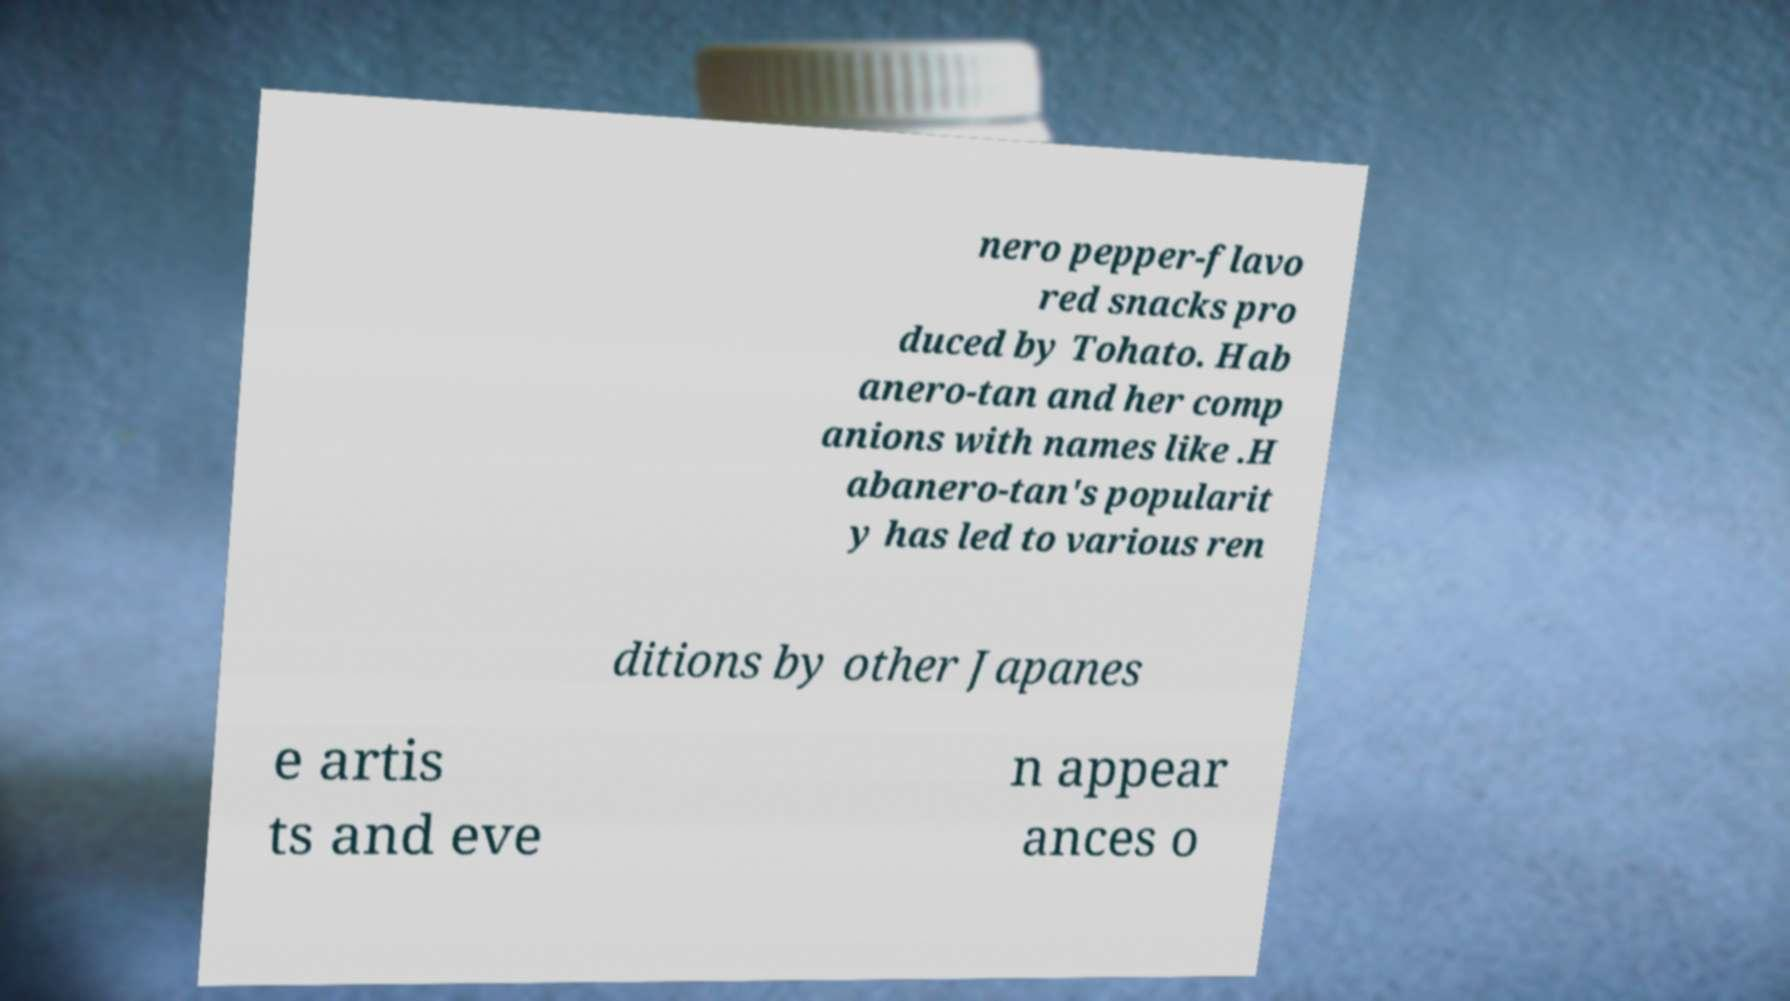Can you accurately transcribe the text from the provided image for me? nero pepper-flavo red snacks pro duced by Tohato. Hab anero-tan and her comp anions with names like .H abanero-tan's popularit y has led to various ren ditions by other Japanes e artis ts and eve n appear ances o 